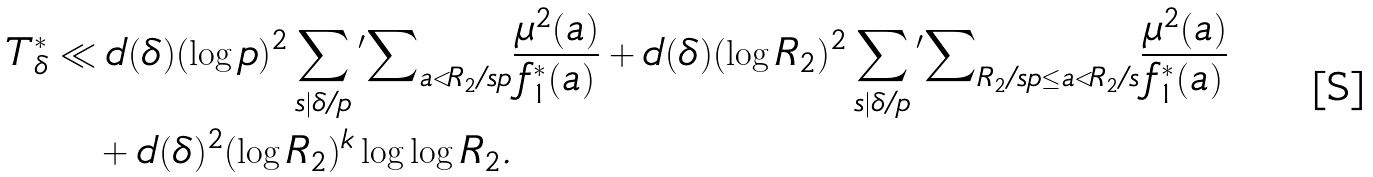<formula> <loc_0><loc_0><loc_500><loc_500>T _ { \delta } ^ { * } & \ll d ( \delta ) ( \log { p } ) ^ { 2 } \sum _ { s | \delta / p } { ^ { \prime } } { \sum } _ { \substack { a < R _ { 2 } / s p } } \frac { \mu ^ { 2 } ( a ) } { f _ { 1 } ^ { * } ( a ) } + d ( \delta ) ( \log { R _ { 2 } } ) ^ { 2 } \sum _ { s | \delta / p } { ^ { \prime } } { \sum } _ { \substack { R _ { 2 } / s p \leq a < R _ { 2 } / s } } \frac { \mu ^ { 2 } ( a ) } { f _ { 1 } ^ { * } ( a ) } \\ & \quad + d ( \delta ) ^ { 2 } ( \log { R _ { 2 } } ) ^ { k } \log \log { R _ { 2 } } .</formula> 